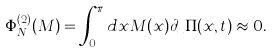Convert formula to latex. <formula><loc_0><loc_0><loc_500><loc_500>\Phi ^ { ( 2 ) } _ { N } ( M ) = \int _ { 0 } ^ { \pi } d x M ( x ) \partial _ { x } \Pi ( x , t ) \approx 0 .</formula> 